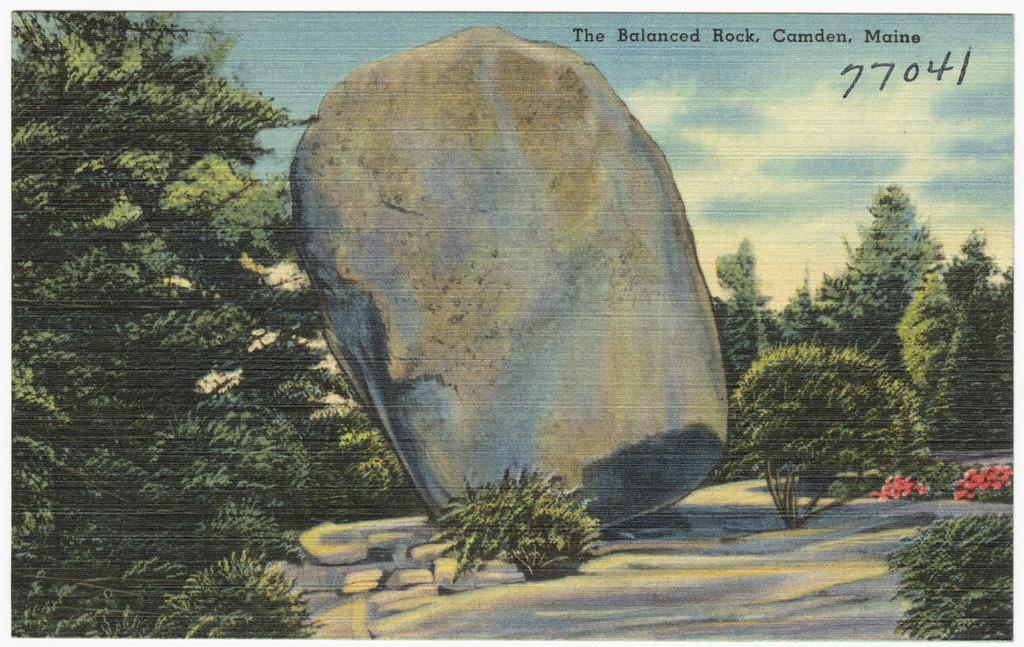<image>
Render a clear and concise summary of the photo. A postcard from The Balanced Rock in Maine is numbered 77041. 